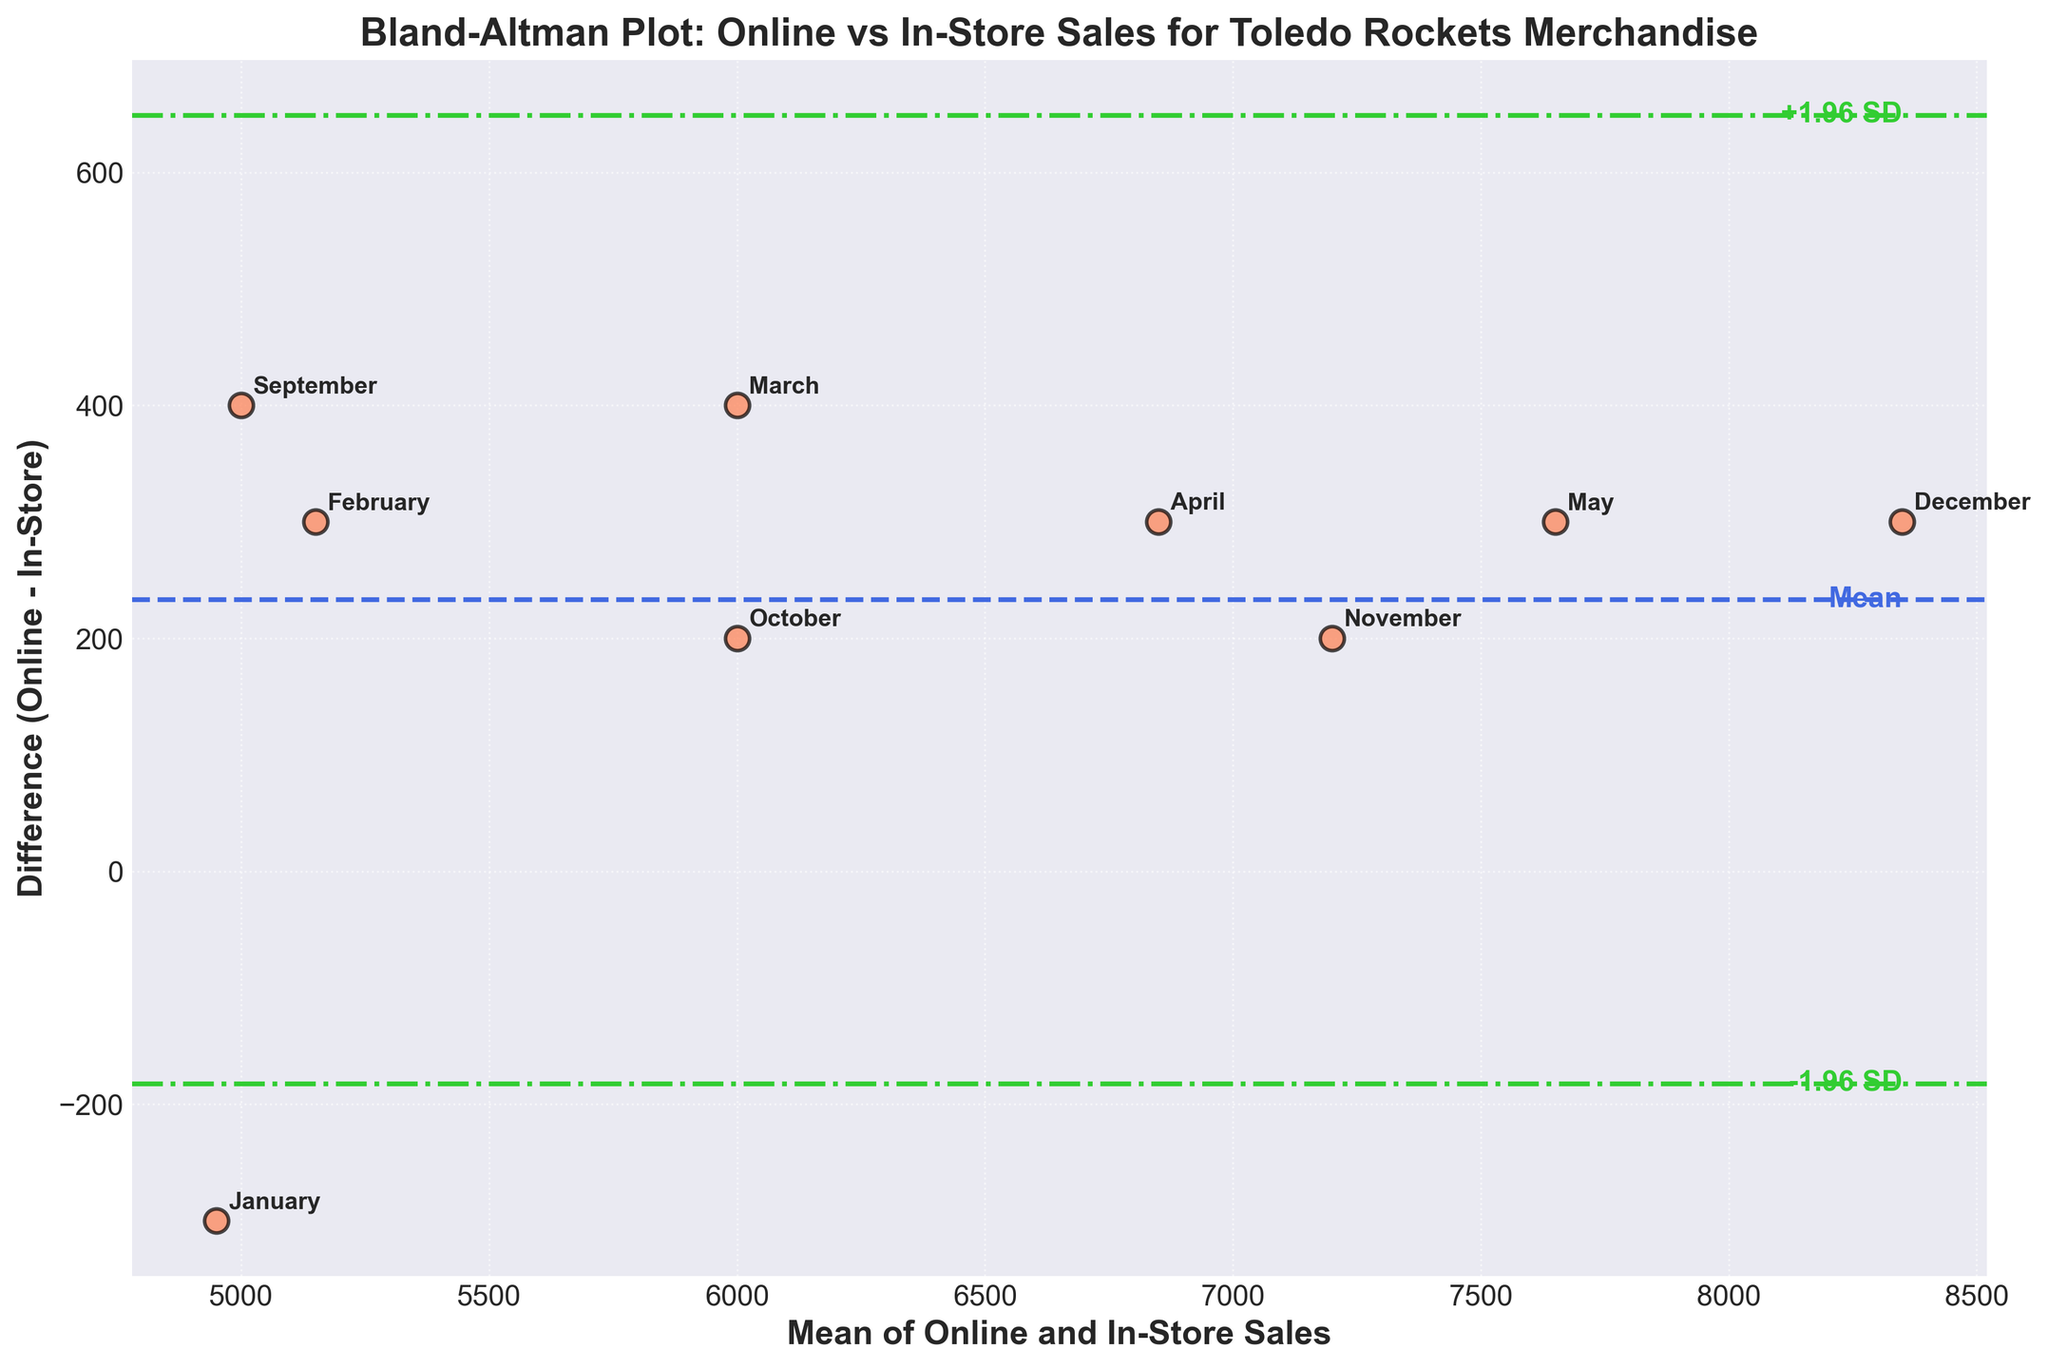What is the title of the plot? The title is prominently displayed at the top of the plot in bold text. It reads "Bland-Altman Plot: Online vs In-Store Sales for Toledo Rockets Merchandise."
Answer: Bland-Altman Plot: Online vs In-Store Sales for Toledo Rockets Merchandise What do the x-axis and y-axis represent? The x-axis represents 'Mean of Online and In-Store Sales,' and the y-axis represents 'Difference (Online - In-Store).' These axis labels are prominently displayed in bold text.
Answer: Mean of Online and In-Store Sales; Difference (Online - In-Store) What color is used for the data points in the scatter plot? The data points in the scatter plot are orange with black edges. This color is chosen to make the points stand out against the dark grid background.
Answer: Orange with black edges How many data points are shown in the plot? There are nine data points in the plot, each representing the difference between online and in-store sales for different months. Each point is labeled with the corresponding month.
Answer: Nine What is the mean difference between online and in-store sales? The mean difference is represented by a dashed blue line and is annotated as 'Mean' on the plot. By reading the text annotation next to the line, we can see the mean difference is clearly indicated.
Answer: Mean difference is represented, no specific value given Which month shows the largest positive difference between online and in-store sales? By examining the scatter points, the highest point above the x-axis represents the largest positive difference. The month label next to the highest point is "December."
Answer: December What are the limits of agreement (LoA) in the plot? The limits of agreement are indicated by two green dashed-dotted lines. They are labeled as '-1.96 SD' for the lower limit and '+1.96 SD' for the upper limit.
Answer: Indicated by lines, no specific values given Is there any month where in-store sales exceed online sales? By observing the points on the plot, any point below the x-axis (y=0) indicates that in-store sales exceed online sales. The point labeled "January" lies below the x-axis.
Answer: January What is the difference in sales for November? The November data point appears above the mean, indicating the difference between online and in-store sales is positive for November. By observing its position relative to the y-axis, it is somewhere between +200 to +300.
Answer: Between +200 to +300 How is the variability in sales difference represented in the plot? Variability is represented by the spread of the data points along the y-axis. The standard deviation lines (+1.96 SD and -1.96 SD) help visualize the extent of this variability. A larger spread indicates greater variability.
Answer: Spread along the y-axis, bounded by ±1.96 SD lines 